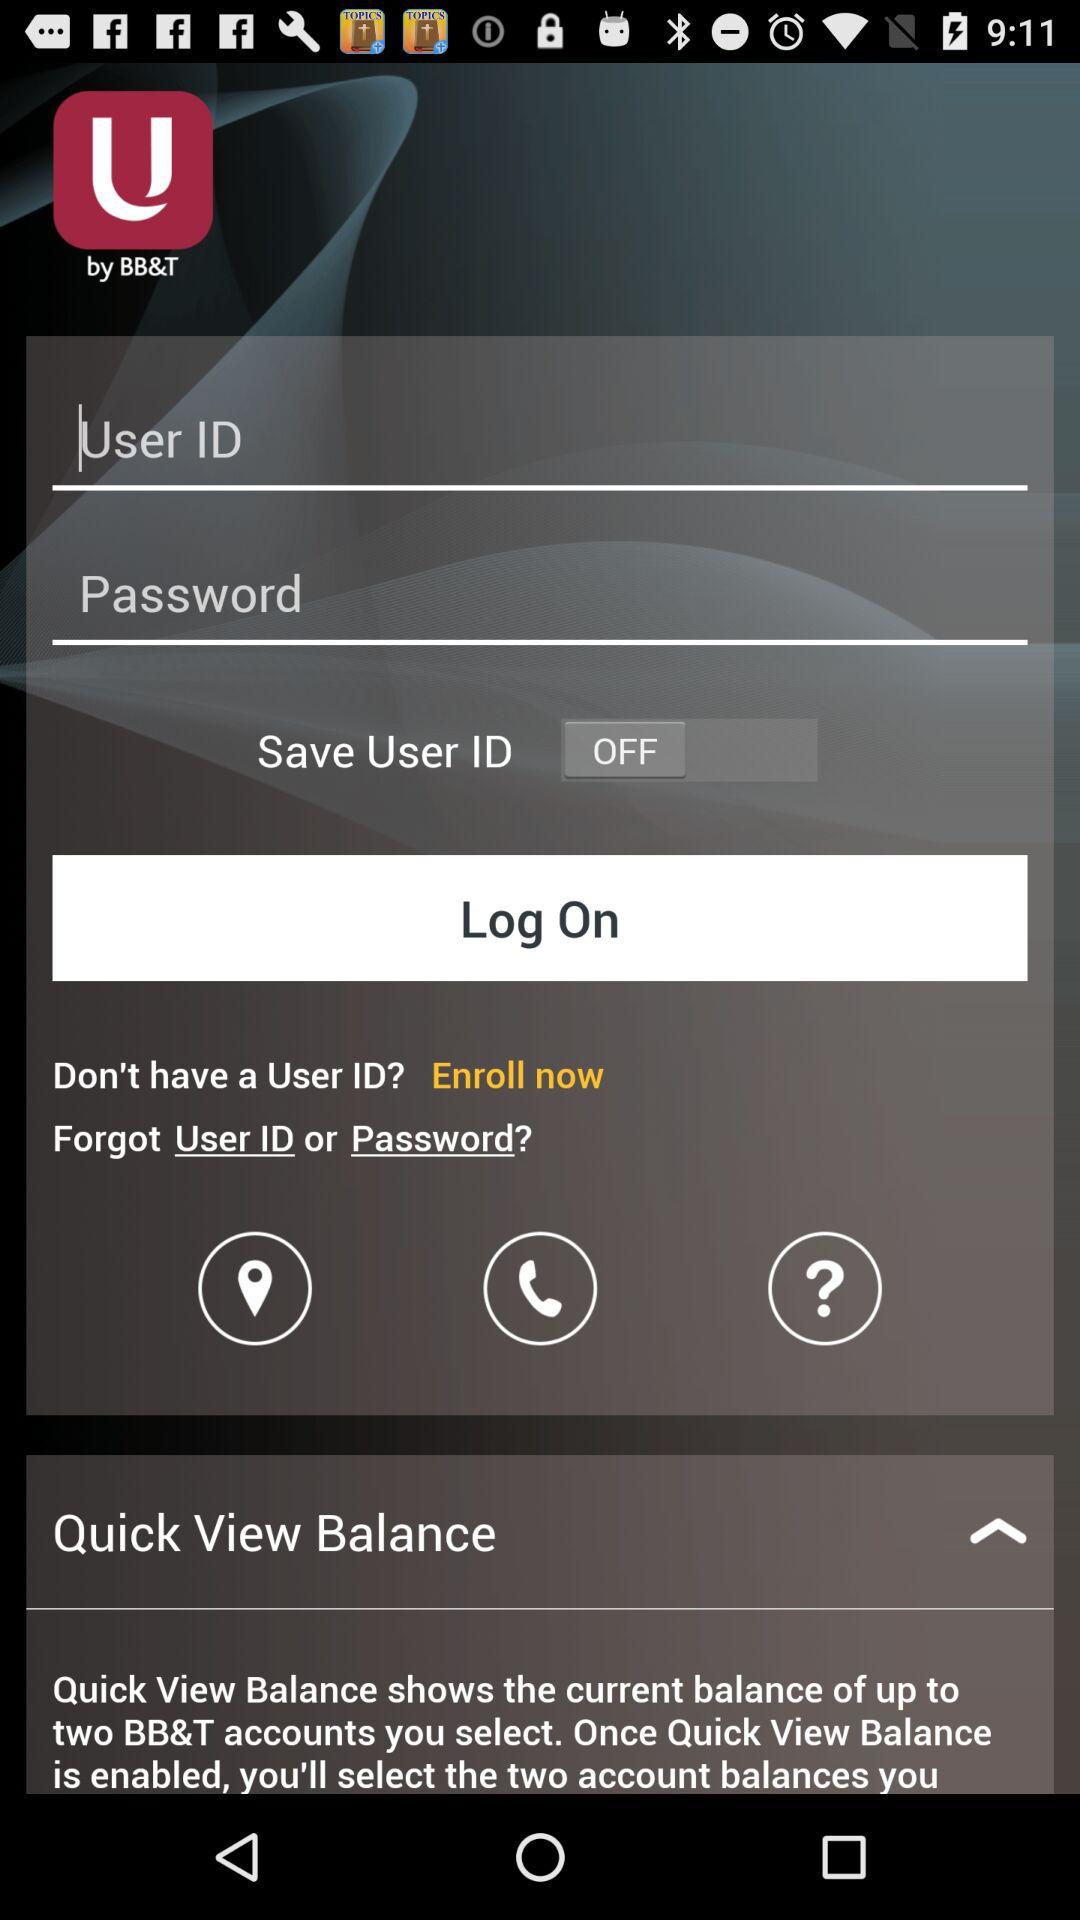What's the status of "Save User ID"? The status is "off". 